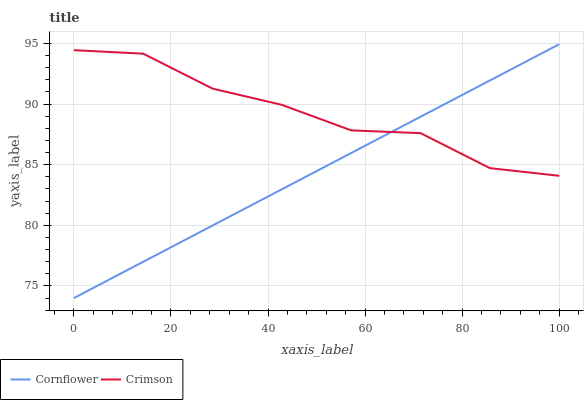Does Cornflower have the maximum area under the curve?
Answer yes or no. No. Is Cornflower the roughest?
Answer yes or no. No. 